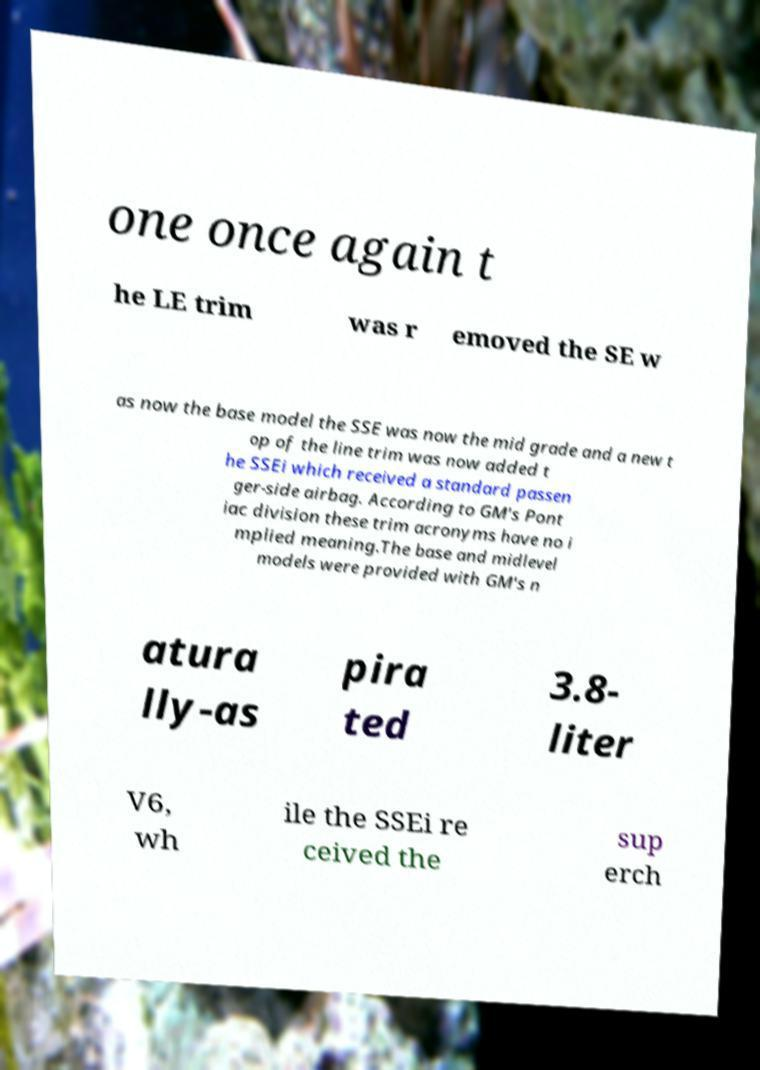What messages or text are displayed in this image? I need them in a readable, typed format. one once again t he LE trim was r emoved the SE w as now the base model the SSE was now the mid grade and a new t op of the line trim was now added t he SSEi which received a standard passen ger-side airbag. According to GM's Pont iac division these trim acronyms have no i mplied meaning.The base and midlevel models were provided with GM's n atura lly-as pira ted 3.8- liter V6, wh ile the SSEi re ceived the sup erch 